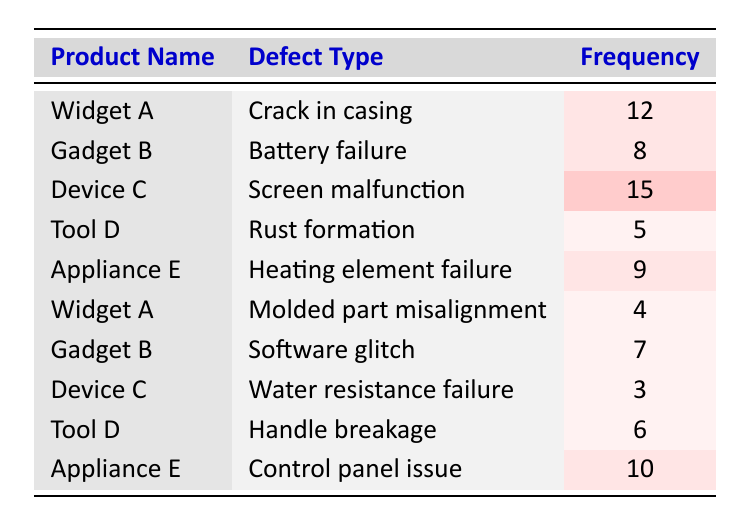What is the defect type for Widget A? The table lists Widget A with two defect types: "Crack in casing" and "Molded part misalignment". Since the question asks for a specific defect type, we can say it has both, but only the first defect type (listed first in the table) is relevant without further context.
Answer: Crack in casing Which product has the highest frequency of reported defects? To find the highest frequency, we review the frequency column. The highest frequency value is 15, attributed to "Device C" for the defect type "Screen malfunction".
Answer: Device C What is the total frequency of defects for Gadget B? Gadget B has two defect types listed: "Battery failure" with a frequency of 8 and "Software glitch" with a frequency of 7. We can calculate the total frequency by summing these two values: 8 + 7 = 15.
Answer: 15 Is there any product that has more than one type of defect reported? By checking the table, we see that Widget A has 2 types of defects, Gadget B has 2 types as well, and Device C also has its distinct defect type. Therefore, there are products with more than one type of defect.
Answer: Yes What is the average defect frequency for Appliance E? Appliance E has two defect types: "Heating element failure" with a frequency of 9 and "Control panel issue" with a frequency of 10. The average is calculated as (9 + 10) / 2 = 19 / 2 = 9.5.
Answer: 9.5 What is the difference in frequency between the highest defect type and the lowest defect type? The highest frequency is 15 for Device C, while the lowest frequency observed is 3 for Device C's "Water resistance failure." The difference can be calculated as: 15 - 3 = 12.
Answer: 12 How many products have a defect frequency of 6 or lower? In the table, the products are assessed for frequencies. Tool D ("Rust formation" and "Handle breakage") has frequencies of 5 and 6 respectively, and Device C's water resistance failure has a frequency of 3. Thus, the total count of products with a frequency of 6 or lower is 3.
Answer: 3 Is the frequency for 'Molded part misalignment' higher than 'Battery failure'? The frequency for 'Molded part misalignment' (4) is compared with 'Battery failure' (8). Since 4 is less than 8, this is a false statement.
Answer: No What is the sum of all defect frequencies for Tool D? Tool D has two defect types with frequencies: "Rust formation" (5) and "Handle breakage" (6). To find the sum, we add these values: 5 + 6 = 11.
Answer: 11 